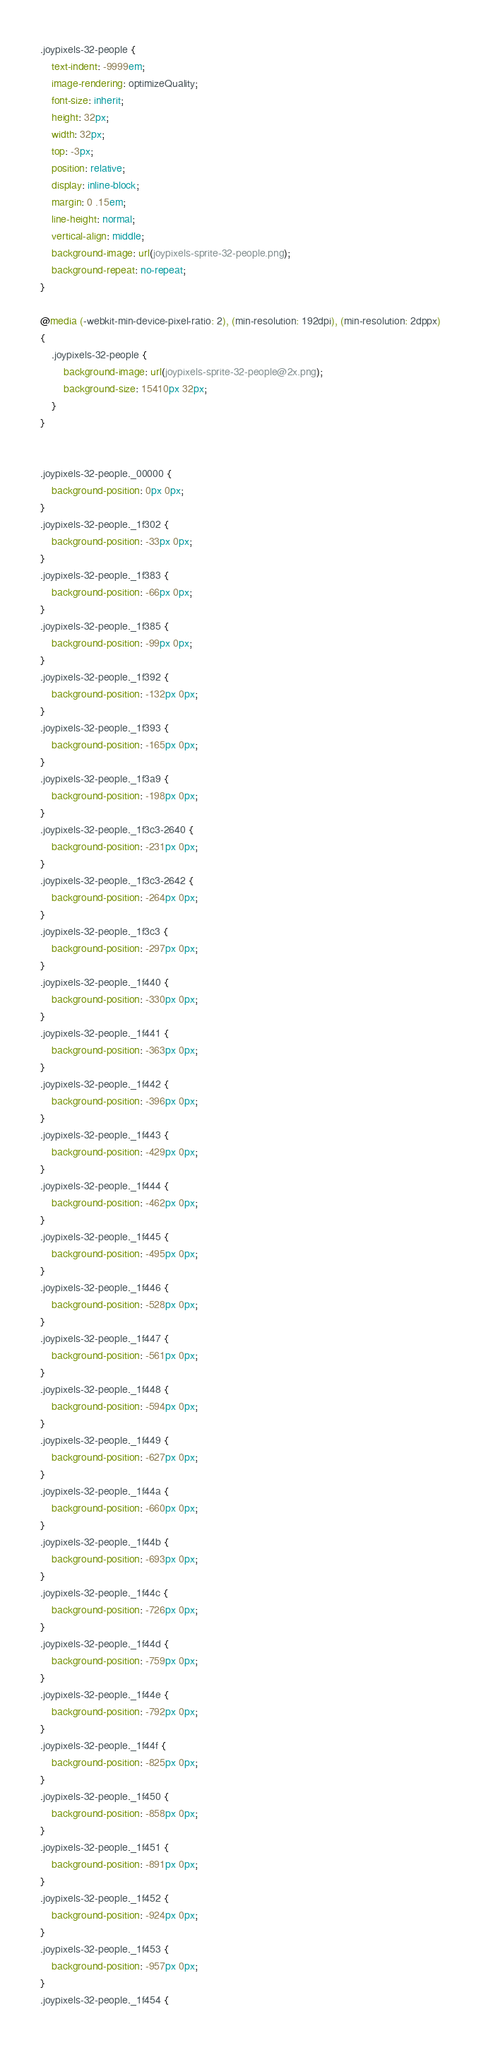<code> <loc_0><loc_0><loc_500><loc_500><_CSS_>.joypixels-32-people {
    text-indent: -9999em;
    image-rendering: optimizeQuality;
    font-size: inherit;
    height: 32px;
    width: 32px;
    top: -3px;
    position: relative;
    display: inline-block;
    margin: 0 .15em;
    line-height: normal;
    vertical-align: middle;
    background-image: url(joypixels-sprite-32-people.png);
    background-repeat: no-repeat;
}

@media (-webkit-min-device-pixel-ratio: 2), (min-resolution: 192dpi), (min-resolution: 2dppx)
{
    .joypixels-32-people {
        background-image: url(joypixels-sprite-32-people@2x.png);
        background-size: 15410px 32px;
    }
}


.joypixels-32-people._00000 {
    background-position: 0px 0px;
}
.joypixels-32-people._1f302 {
    background-position: -33px 0px;
}
.joypixels-32-people._1f383 {
    background-position: -66px 0px;
}
.joypixels-32-people._1f385 {
    background-position: -99px 0px;
}
.joypixels-32-people._1f392 {
    background-position: -132px 0px;
}
.joypixels-32-people._1f393 {
    background-position: -165px 0px;
}
.joypixels-32-people._1f3a9 {
    background-position: -198px 0px;
}
.joypixels-32-people._1f3c3-2640 {
    background-position: -231px 0px;
}
.joypixels-32-people._1f3c3-2642 {
    background-position: -264px 0px;
}
.joypixels-32-people._1f3c3 {
    background-position: -297px 0px;
}
.joypixels-32-people._1f440 {
    background-position: -330px 0px;
}
.joypixels-32-people._1f441 {
    background-position: -363px 0px;
}
.joypixels-32-people._1f442 {
    background-position: -396px 0px;
}
.joypixels-32-people._1f443 {
    background-position: -429px 0px;
}
.joypixels-32-people._1f444 {
    background-position: -462px 0px;
}
.joypixels-32-people._1f445 {
    background-position: -495px 0px;
}
.joypixels-32-people._1f446 {
    background-position: -528px 0px;
}
.joypixels-32-people._1f447 {
    background-position: -561px 0px;
}
.joypixels-32-people._1f448 {
    background-position: -594px 0px;
}
.joypixels-32-people._1f449 {
    background-position: -627px 0px;
}
.joypixels-32-people._1f44a {
    background-position: -660px 0px;
}
.joypixels-32-people._1f44b {
    background-position: -693px 0px;
}
.joypixels-32-people._1f44c {
    background-position: -726px 0px;
}
.joypixels-32-people._1f44d {
    background-position: -759px 0px;
}
.joypixels-32-people._1f44e {
    background-position: -792px 0px;
}
.joypixels-32-people._1f44f {
    background-position: -825px 0px;
}
.joypixels-32-people._1f450 {
    background-position: -858px 0px;
}
.joypixels-32-people._1f451 {
    background-position: -891px 0px;
}
.joypixels-32-people._1f452 {
    background-position: -924px 0px;
}
.joypixels-32-people._1f453 {
    background-position: -957px 0px;
}
.joypixels-32-people._1f454 {</code> 